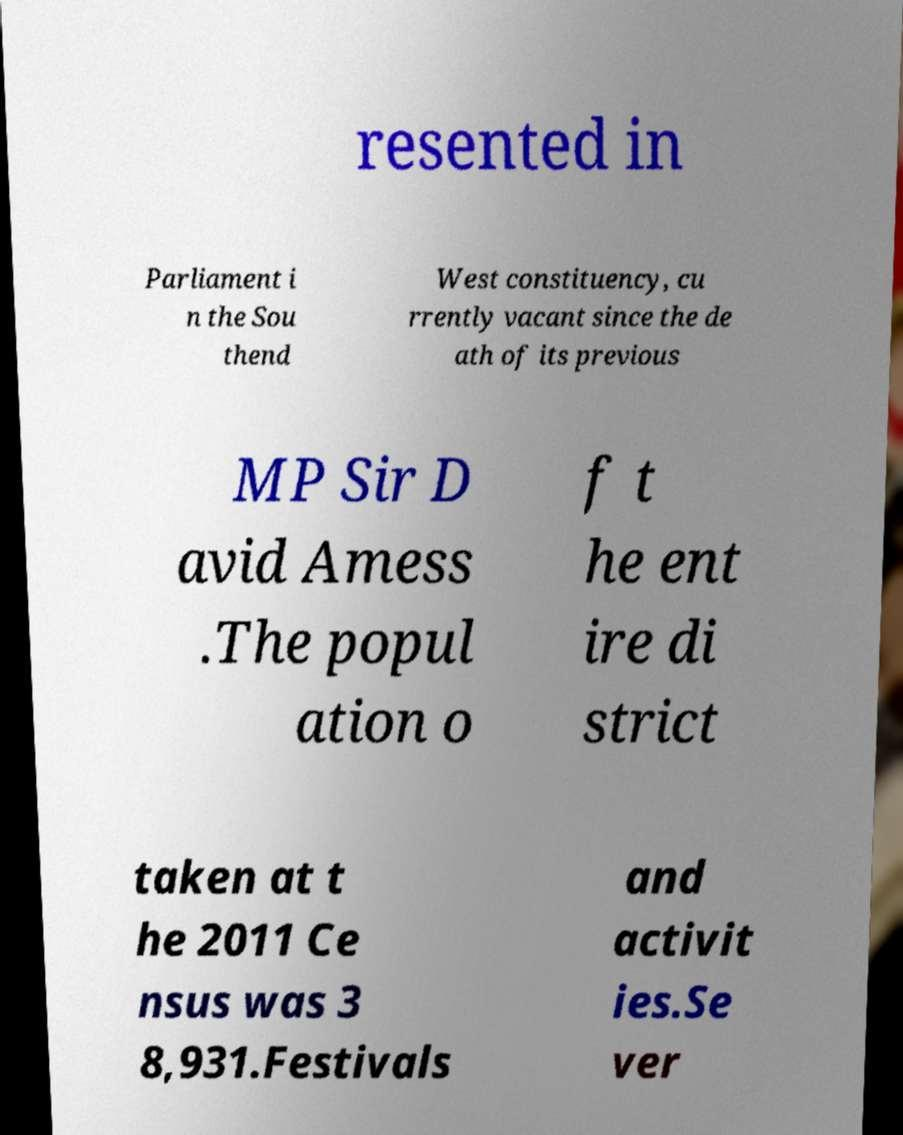Please identify and transcribe the text found in this image. resented in Parliament i n the Sou thend West constituency, cu rrently vacant since the de ath of its previous MP Sir D avid Amess .The popul ation o f t he ent ire di strict taken at t he 2011 Ce nsus was 3 8,931.Festivals and activit ies.Se ver 